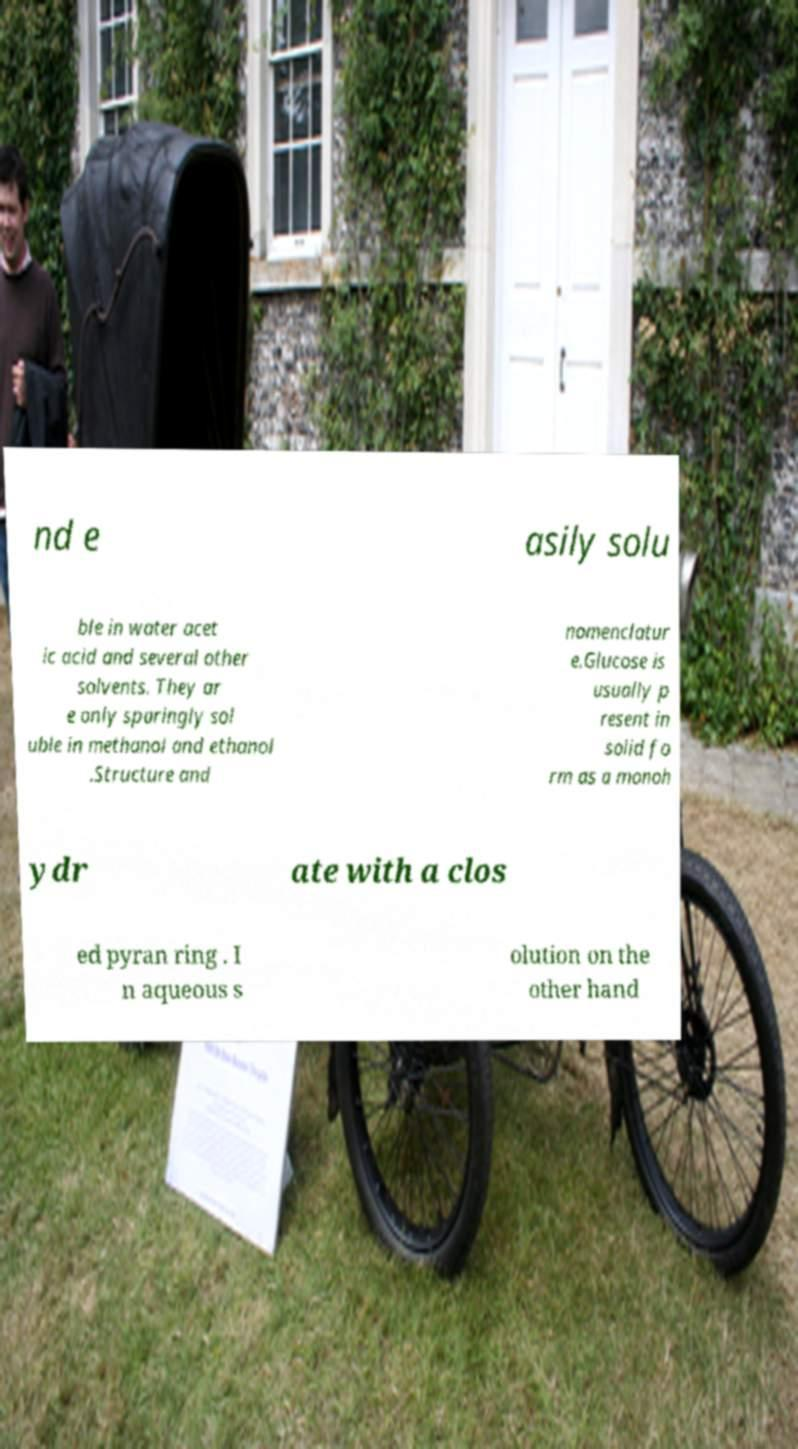There's text embedded in this image that I need extracted. Can you transcribe it verbatim? nd e asily solu ble in water acet ic acid and several other solvents. They ar e only sparingly sol uble in methanol and ethanol .Structure and nomenclatur e.Glucose is usually p resent in solid fo rm as a monoh ydr ate with a clos ed pyran ring . I n aqueous s olution on the other hand 